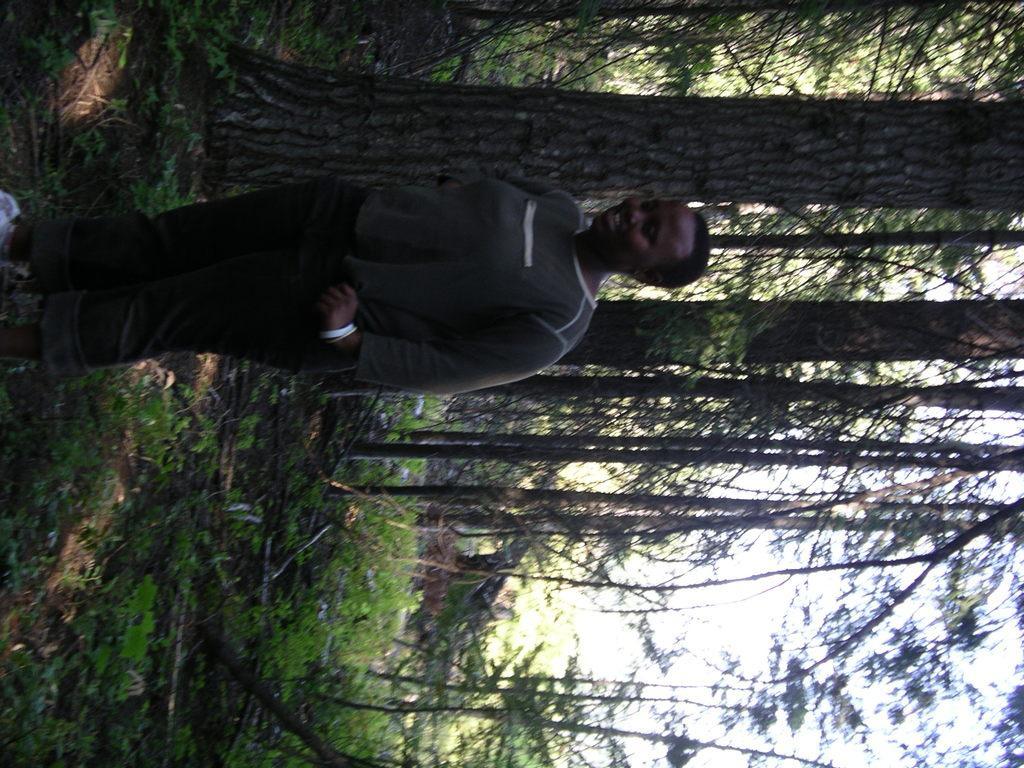Please provide a concise description of this image. In this image I can see the person with the dress. In the background I can see many trees and the sky. 